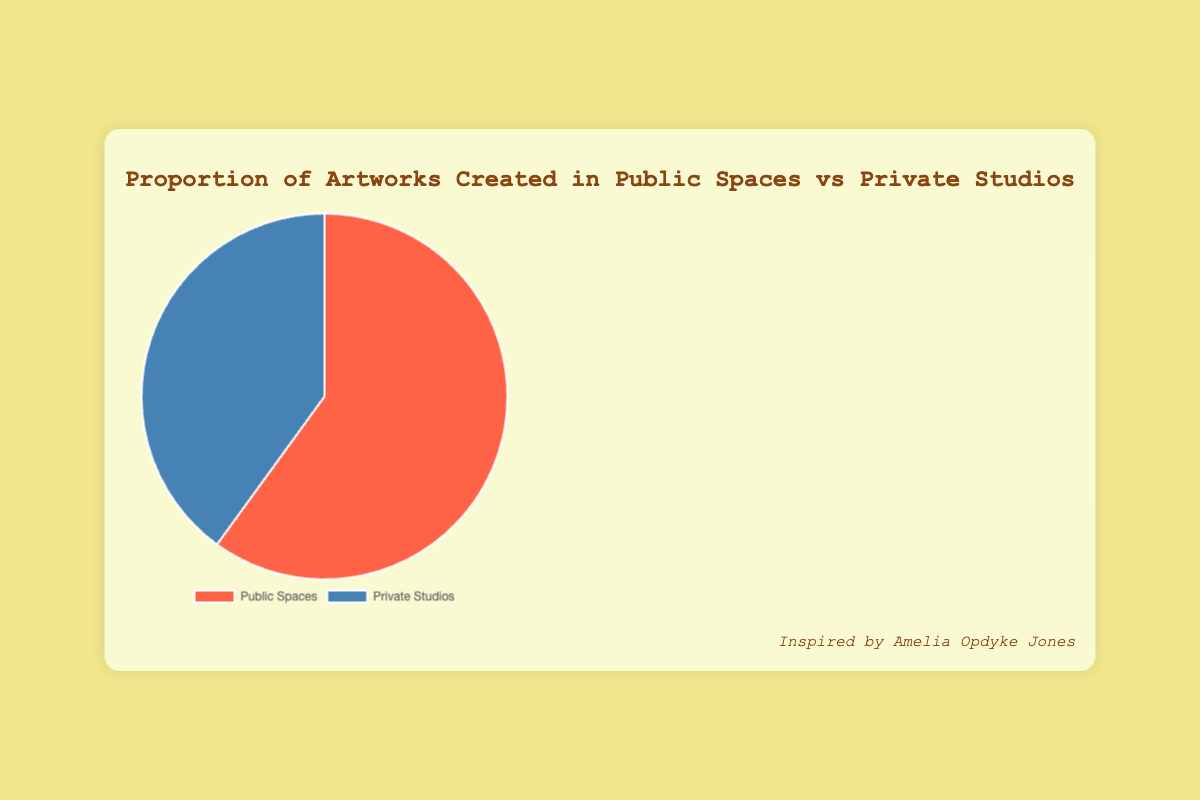What percentage of artworks were created in Public Spaces? The pie chart shows that 60% of the artworks were created in Public Spaces.
Answer: 60% What is the percentage difference between artworks created in Public Spaces and Private Studios? The difference can be calculated as 60% (Public Spaces) - 40% (Private Studios) = 20%.
Answer: 20% Which category has more artworks, Public Spaces or Private Studios? According to the pie chart, Public Spaces have a higher percentage (60%) compared to Private Studios (40%).
Answer: Public Spaces If I want to see most artworks in a single category, which one should I explore? Based on the chart, Public Spaces have the majority of artworks at 60%.
Answer: Public Spaces What is the combined percentage of artworks created either in Public Spaces or Private Studios? The combined percentage is 60% (Public Spaces) + 40% (Private Studios) = 100%.
Answer: 100% Which section of the pie chart is blue? The pie chart shows that the 'Private Studios' category is represented in blue.
Answer: Private Studios How many times larger is the proportion of Public Spaces artworks compared to Private Studios? The proportion of Public Spaces artworks is 60%, and for Private Studios, it is 40%. The ratio is 60/40 = 1.5 times.
Answer: 1.5 times Which category has a smaller proportion of artworks, Public Spaces or Private Studios? Private Studios have a smaller proportion of artworks at 40%.
Answer: Private Studios What color represents the larger segment of the pie chart? The larger segment of the pie chart, representing Public Spaces, is colored red.
Answer: Red 